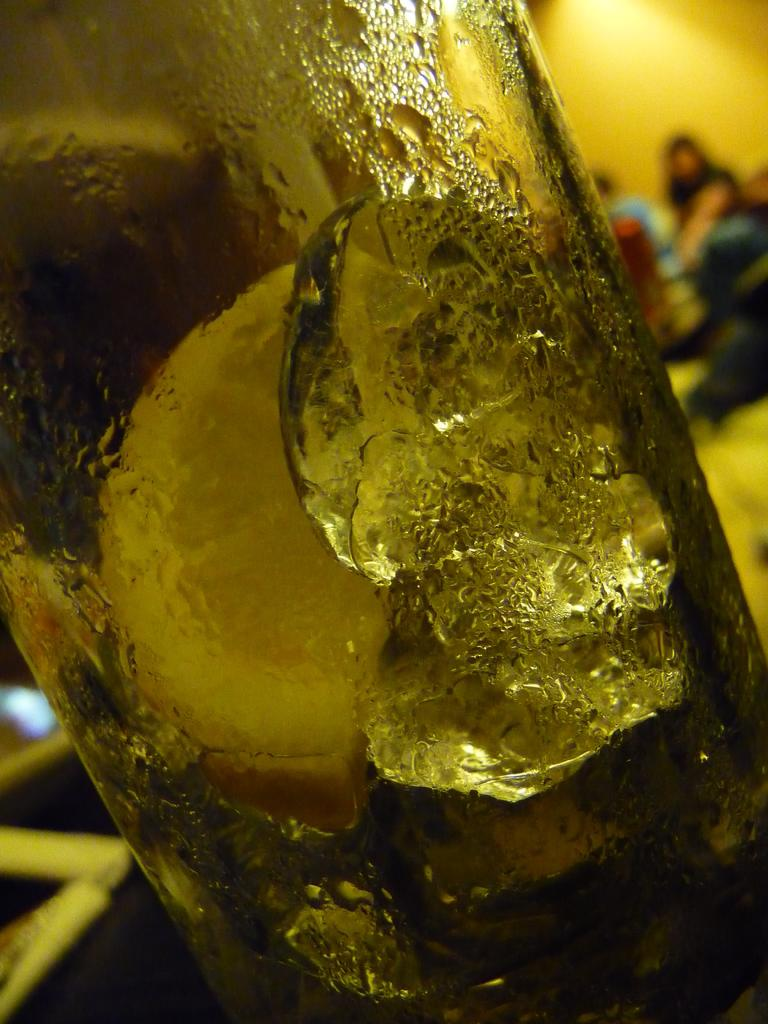What object can be seen in the image? There is a glass bottle in the image. Can you describe the people in the background of the image? Unfortunately, the facts provided do not give any details about the persons in the background. What might be the purpose of the glass bottle in the image? Without more context, it is difficult to determine the purpose of the glass bottle. It could be a container for a beverage, a decorative item, or something else entirely. What flavor of toothpaste is the girl using in the image? There is no girl or toothpaste present in the image. 